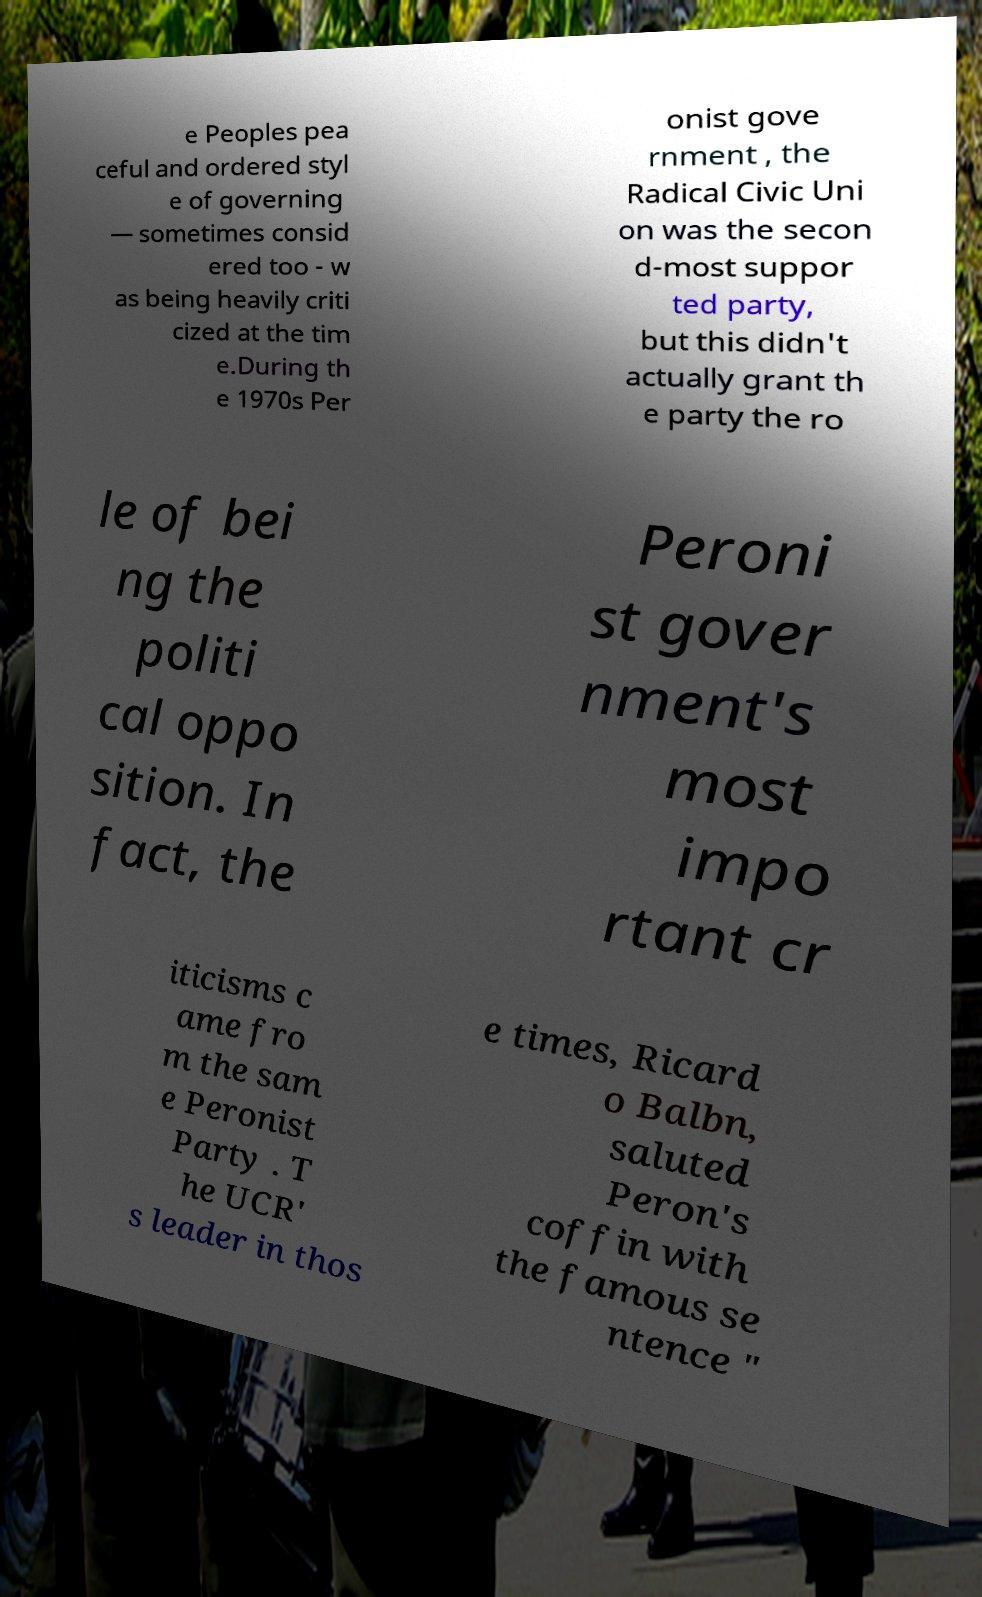What messages or text are displayed in this image? I need them in a readable, typed format. e Peoples pea ceful and ordered styl e of governing — sometimes consid ered too - w as being heavily criti cized at the tim e.During th e 1970s Per onist gove rnment , the Radical Civic Uni on was the secon d-most suppor ted party, but this didn't actually grant th e party the ro le of bei ng the politi cal oppo sition. In fact, the Peroni st gover nment's most impo rtant cr iticisms c ame fro m the sam e Peronist Party . T he UCR' s leader in thos e times, Ricard o Balbn, saluted Peron's coffin with the famous se ntence " 